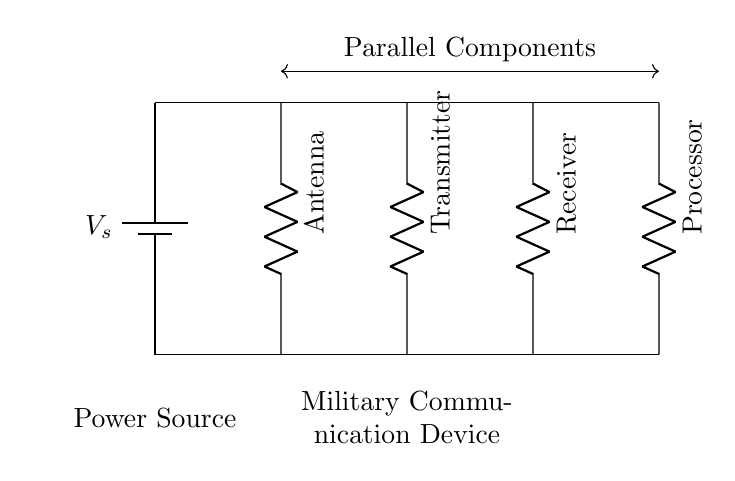What is the power source in this circuit? The power source is identified as a battery, labeled as Vs in the circuit diagram. This indicates the supply voltage for the entire circuit.
Answer: battery How many components are connected in parallel in this circuit? There are four components connected in parallel: an antenna, a transmitter, a receiver, and a processor. Each of these components has its own individual branch, which is characteristic of parallel circuits.
Answer: four What is the role of the processor in this parallel circuit? The processor serves as one of the parallel components, indicating that it processes signals received from the other devices (antenna, transmitter, receiver) simultaneously.
Answer: processing signals If the voltage from the power source is 12V, what is the voltage across each component? In parallel circuits, the voltage across all components is the same as the source voltage. Therefore, each component (antenna, transmitter, receiver, processor) experiences the full 12V.
Answer: 12V What type of circuit is represented in this diagram? The diagram represents a parallel circuit, as evidenced by the parallel arrangement of its components connected to the same voltage source, allowing simultaneous operation.
Answer: parallel circuit What is the primary advantage of using a parallel circuit in military communication devices? The primary advantage is that multiple signals can be processed simultaneously, allowing for efficient communication without interference, which is crucial in military operations.
Answer: simultaneous signal processing 